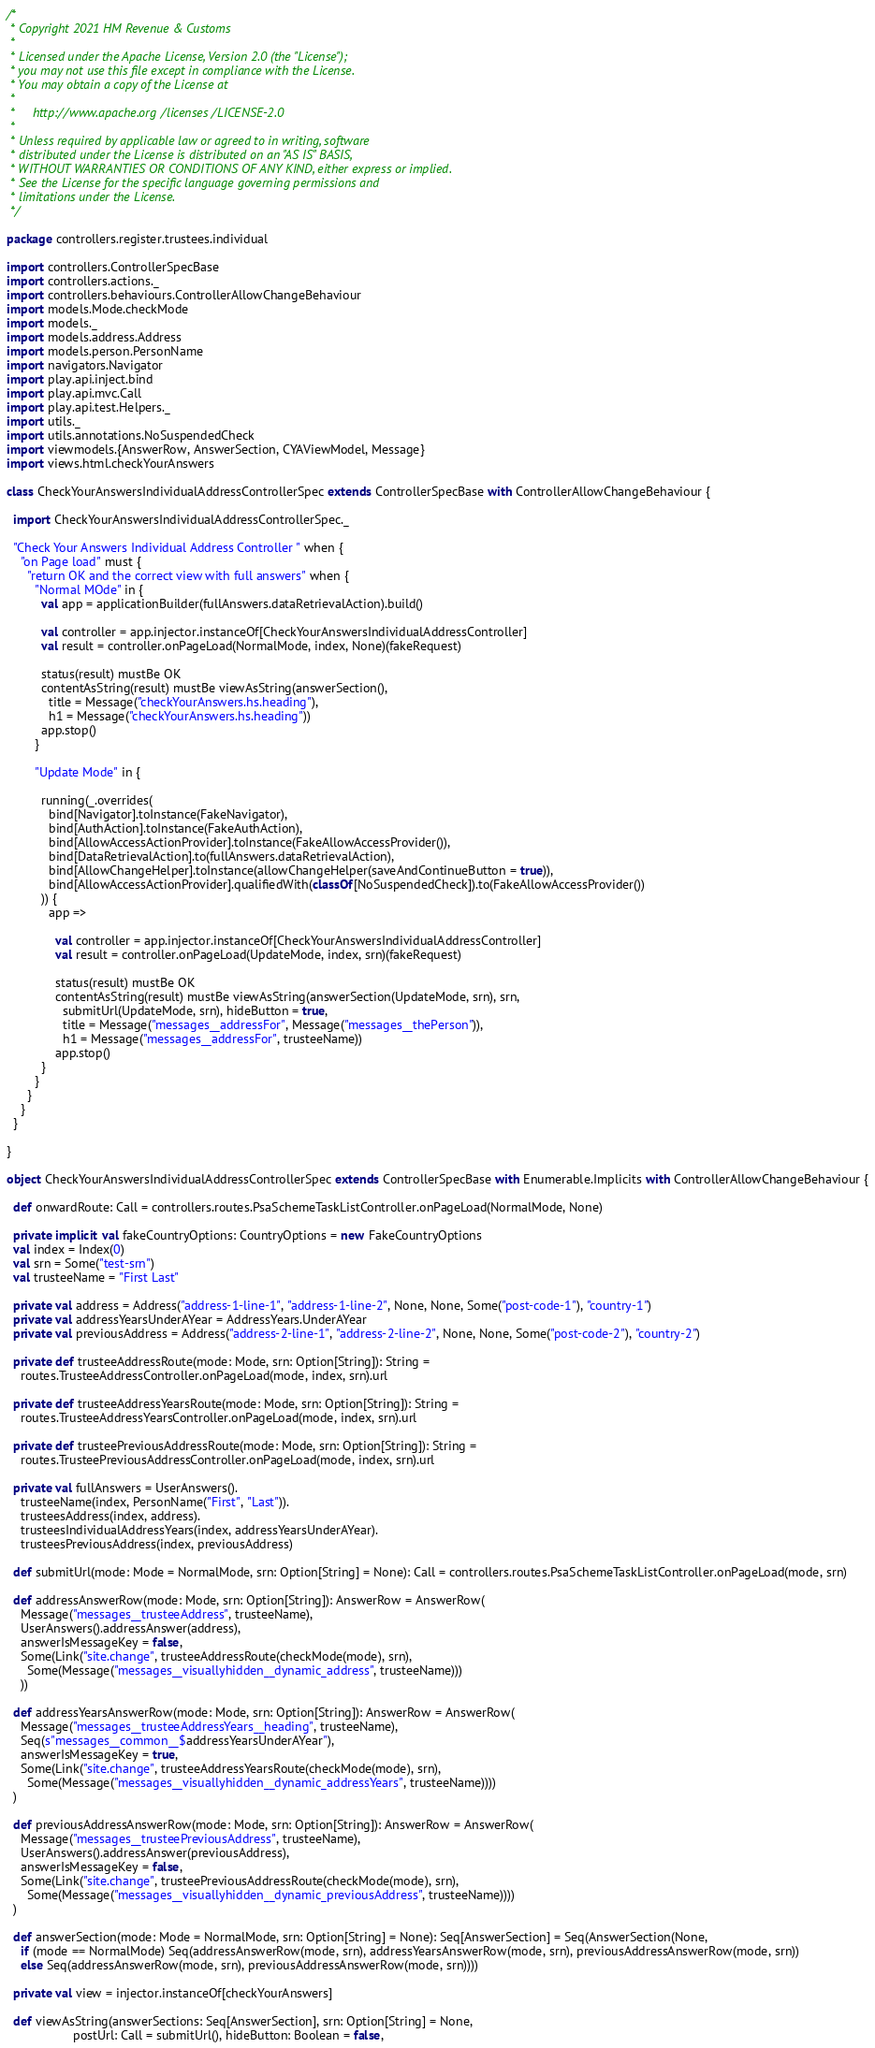<code> <loc_0><loc_0><loc_500><loc_500><_Scala_>/*
 * Copyright 2021 HM Revenue & Customs
 *
 * Licensed under the Apache License, Version 2.0 (the "License");
 * you may not use this file except in compliance with the License.
 * You may obtain a copy of the License at
 *
 *     http://www.apache.org/licenses/LICENSE-2.0
 *
 * Unless required by applicable law or agreed to in writing, software
 * distributed under the License is distributed on an "AS IS" BASIS,
 * WITHOUT WARRANTIES OR CONDITIONS OF ANY KIND, either express or implied.
 * See the License for the specific language governing permissions and
 * limitations under the License.
 */

package controllers.register.trustees.individual

import controllers.ControllerSpecBase
import controllers.actions._
import controllers.behaviours.ControllerAllowChangeBehaviour
import models.Mode.checkMode
import models._
import models.address.Address
import models.person.PersonName
import navigators.Navigator
import play.api.inject.bind
import play.api.mvc.Call
import play.api.test.Helpers._
import utils._
import utils.annotations.NoSuspendedCheck
import viewmodels.{AnswerRow, AnswerSection, CYAViewModel, Message}
import views.html.checkYourAnswers

class CheckYourAnswersIndividualAddressControllerSpec extends ControllerSpecBase with ControllerAllowChangeBehaviour {

  import CheckYourAnswersIndividualAddressControllerSpec._

  "Check Your Answers Individual Address Controller " when {
    "on Page load" must {
      "return OK and the correct view with full answers" when {
        "Normal MOde" in {
          val app = applicationBuilder(fullAnswers.dataRetrievalAction).build()

          val controller = app.injector.instanceOf[CheckYourAnswersIndividualAddressController]
          val result = controller.onPageLoad(NormalMode, index, None)(fakeRequest)

          status(result) mustBe OK
          contentAsString(result) mustBe viewAsString(answerSection(),
            title = Message("checkYourAnswers.hs.heading"),
            h1 = Message("checkYourAnswers.hs.heading"))
          app.stop()
        }

        "Update Mode" in {

          running(_.overrides(
            bind[Navigator].toInstance(FakeNavigator),
            bind[AuthAction].toInstance(FakeAuthAction),
            bind[AllowAccessActionProvider].toInstance(FakeAllowAccessProvider()),
            bind[DataRetrievalAction].to(fullAnswers.dataRetrievalAction),
            bind[AllowChangeHelper].toInstance(allowChangeHelper(saveAndContinueButton = true)),
            bind[AllowAccessActionProvider].qualifiedWith(classOf[NoSuspendedCheck]).to(FakeAllowAccessProvider())
          )) {
            app =>

              val controller = app.injector.instanceOf[CheckYourAnswersIndividualAddressController]
              val result = controller.onPageLoad(UpdateMode, index, srn)(fakeRequest)

              status(result) mustBe OK
              contentAsString(result) mustBe viewAsString(answerSection(UpdateMode, srn), srn,
                submitUrl(UpdateMode, srn), hideButton = true,
                title = Message("messages__addressFor", Message("messages__thePerson")),
                h1 = Message("messages__addressFor", trusteeName))
              app.stop()
          }
        }
      }
    }
  }

}

object CheckYourAnswersIndividualAddressControllerSpec extends ControllerSpecBase with Enumerable.Implicits with ControllerAllowChangeBehaviour {

  def onwardRoute: Call = controllers.routes.PsaSchemeTaskListController.onPageLoad(NormalMode, None)

  private implicit val fakeCountryOptions: CountryOptions = new FakeCountryOptions
  val index = Index(0)
  val srn = Some("test-srn")
  val trusteeName = "First Last"

  private val address = Address("address-1-line-1", "address-1-line-2", None, None, Some("post-code-1"), "country-1")
  private val addressYearsUnderAYear = AddressYears.UnderAYear
  private val previousAddress = Address("address-2-line-1", "address-2-line-2", None, None, Some("post-code-2"), "country-2")

  private def trusteeAddressRoute(mode: Mode, srn: Option[String]): String =
    routes.TrusteeAddressController.onPageLoad(mode, index, srn).url

  private def trusteeAddressYearsRoute(mode: Mode, srn: Option[String]): String =
    routes.TrusteeAddressYearsController.onPageLoad(mode, index, srn).url

  private def trusteePreviousAddressRoute(mode: Mode, srn: Option[String]): String =
    routes.TrusteePreviousAddressController.onPageLoad(mode, index, srn).url

  private val fullAnswers = UserAnswers().
    trusteeName(index, PersonName("First", "Last")).
    trusteesAddress(index, address).
    trusteesIndividualAddressYears(index, addressYearsUnderAYear).
    trusteesPreviousAddress(index, previousAddress)

  def submitUrl(mode: Mode = NormalMode, srn: Option[String] = None): Call = controllers.routes.PsaSchemeTaskListController.onPageLoad(mode, srn)

  def addressAnswerRow(mode: Mode, srn: Option[String]): AnswerRow = AnswerRow(
    Message("messages__trusteeAddress", trusteeName),
    UserAnswers().addressAnswer(address),
    answerIsMessageKey = false,
    Some(Link("site.change", trusteeAddressRoute(checkMode(mode), srn),
      Some(Message("messages__visuallyhidden__dynamic_address", trusteeName)))
    ))

  def addressYearsAnswerRow(mode: Mode, srn: Option[String]): AnswerRow = AnswerRow(
    Message("messages__trusteeAddressYears__heading", trusteeName),
    Seq(s"messages__common__$addressYearsUnderAYear"),
    answerIsMessageKey = true,
    Some(Link("site.change", trusteeAddressYearsRoute(checkMode(mode), srn),
      Some(Message("messages__visuallyhidden__dynamic_addressYears", trusteeName))))
  )

  def previousAddressAnswerRow(mode: Mode, srn: Option[String]): AnswerRow = AnswerRow(
    Message("messages__trusteePreviousAddress", trusteeName),
    UserAnswers().addressAnswer(previousAddress),
    answerIsMessageKey = false,
    Some(Link("site.change", trusteePreviousAddressRoute(checkMode(mode), srn),
      Some(Message("messages__visuallyhidden__dynamic_previousAddress", trusteeName))))
  )

  def answerSection(mode: Mode = NormalMode, srn: Option[String] = None): Seq[AnswerSection] = Seq(AnswerSection(None,
    if (mode == NormalMode) Seq(addressAnswerRow(mode, srn), addressYearsAnswerRow(mode, srn), previousAddressAnswerRow(mode, srn))
    else Seq(addressAnswerRow(mode, srn), previousAddressAnswerRow(mode, srn))))

  private val view = injector.instanceOf[checkYourAnswers]

  def viewAsString(answerSections: Seq[AnswerSection], srn: Option[String] = None,
                   postUrl: Call = submitUrl(), hideButton: Boolean = false,</code> 